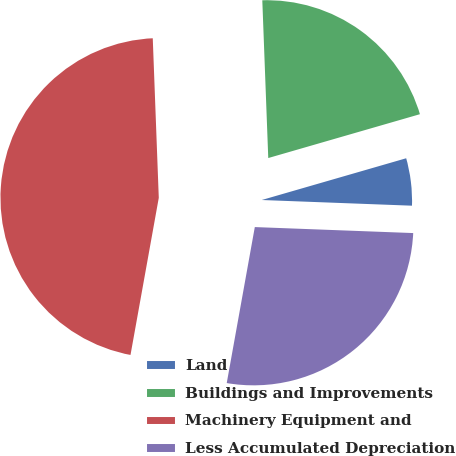Convert chart. <chart><loc_0><loc_0><loc_500><loc_500><pie_chart><fcel>Land<fcel>Buildings and Improvements<fcel>Machinery Equipment and<fcel>Less Accumulated Depreciation<nl><fcel>5.08%<fcel>21.12%<fcel>46.56%<fcel>27.23%<nl></chart> 